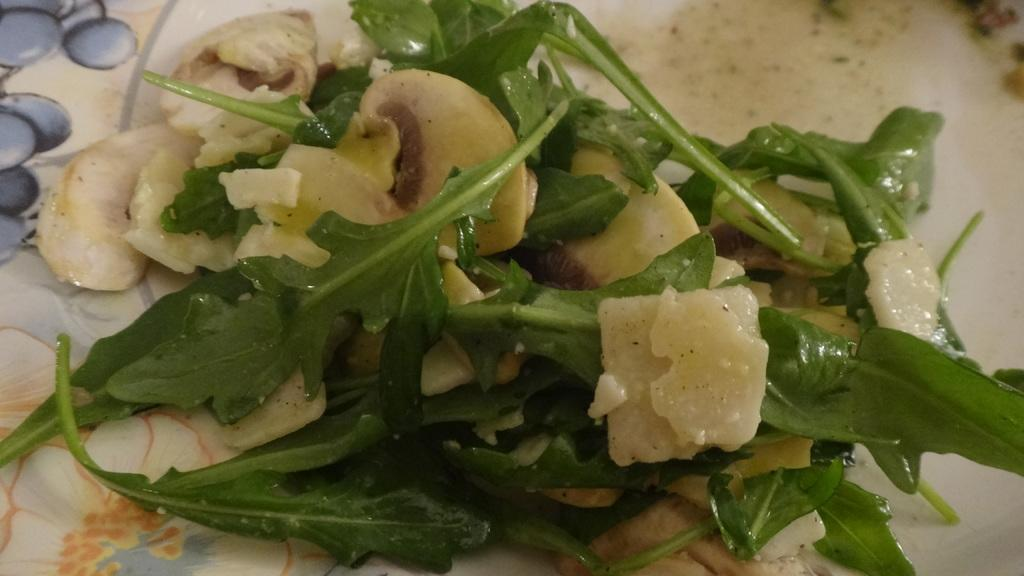What is the main subject in the foreground of the image? There is food in the foreground of the image. Can you describe the type of food that is visible? There is a green leafy vegetable on a platter in the foreground of the image. What emotion is the green leafy vegetable expressing in the image? The green leafy vegetable does not express emotions, as it is an inanimate object. 